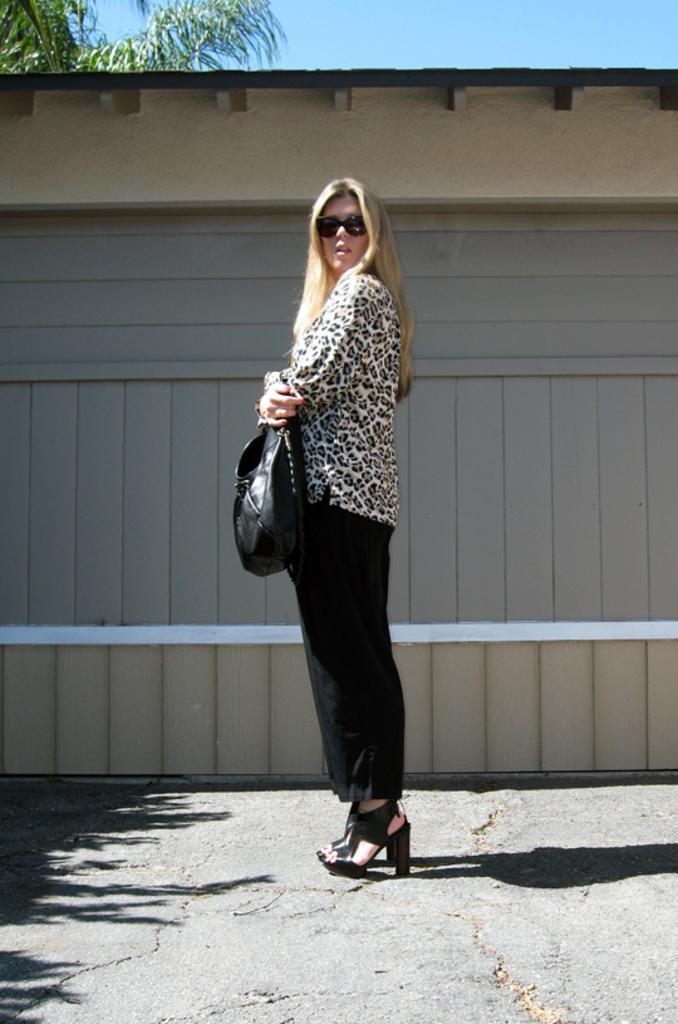Describe this image in one or two sentences. In this image we can see a woman standing on the road and holding a bag in her hands. In the background there are shed, sky and tree. 